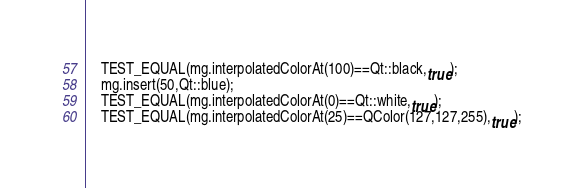Convert code to text. <code><loc_0><loc_0><loc_500><loc_500><_C++_>	TEST_EQUAL(mg.interpolatedColorAt(100)==Qt::black,true);
	mg.insert(50,Qt::blue);
	TEST_EQUAL(mg.interpolatedColorAt(0)==Qt::white,true);
	TEST_EQUAL(mg.interpolatedColorAt(25)==QColor(127,127,255),true);</code> 